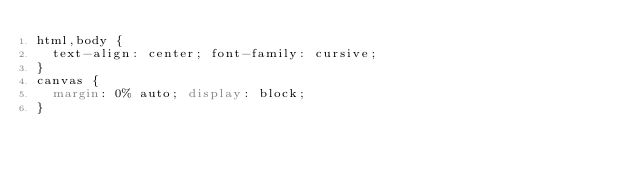<code> <loc_0><loc_0><loc_500><loc_500><_CSS_>html,body {
  text-align: center; font-family: cursive;
}
canvas {
  margin: 0% auto; display: block;
}

</code> 